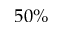<formula> <loc_0><loc_0><loc_500><loc_500>5 0 \%</formula> 